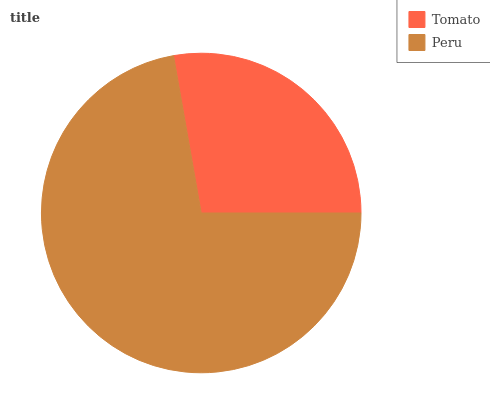Is Tomato the minimum?
Answer yes or no. Yes. Is Peru the maximum?
Answer yes or no. Yes. Is Peru the minimum?
Answer yes or no. No. Is Peru greater than Tomato?
Answer yes or no. Yes. Is Tomato less than Peru?
Answer yes or no. Yes. Is Tomato greater than Peru?
Answer yes or no. No. Is Peru less than Tomato?
Answer yes or no. No. Is Peru the high median?
Answer yes or no. Yes. Is Tomato the low median?
Answer yes or no. Yes. Is Tomato the high median?
Answer yes or no. No. Is Peru the low median?
Answer yes or no. No. 